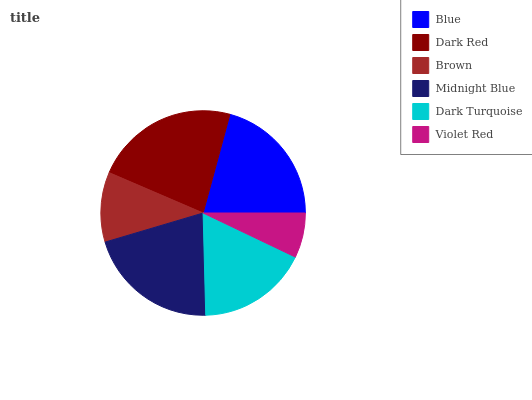Is Violet Red the minimum?
Answer yes or no. Yes. Is Dark Red the maximum?
Answer yes or no. Yes. Is Brown the minimum?
Answer yes or no. No. Is Brown the maximum?
Answer yes or no. No. Is Dark Red greater than Brown?
Answer yes or no. Yes. Is Brown less than Dark Red?
Answer yes or no. Yes. Is Brown greater than Dark Red?
Answer yes or no. No. Is Dark Red less than Brown?
Answer yes or no. No. Is Blue the high median?
Answer yes or no. Yes. Is Dark Turquoise the low median?
Answer yes or no. Yes. Is Violet Red the high median?
Answer yes or no. No. Is Dark Red the low median?
Answer yes or no. No. 